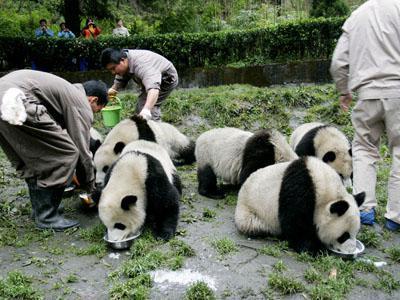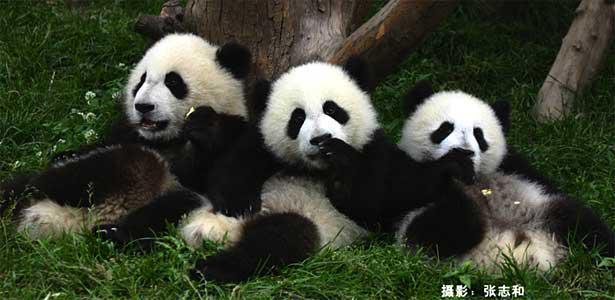The first image is the image on the left, the second image is the image on the right. Analyze the images presented: Is the assertion "An image with exactly four pandas includes one with its front paws outspread, reaching toward the panda on either side of it." valid? Answer yes or no. No. The first image is the image on the left, the second image is the image on the right. Examine the images to the left and right. Is the description "The image to the left features exactly four pandas." accurate? Answer yes or no. No. 